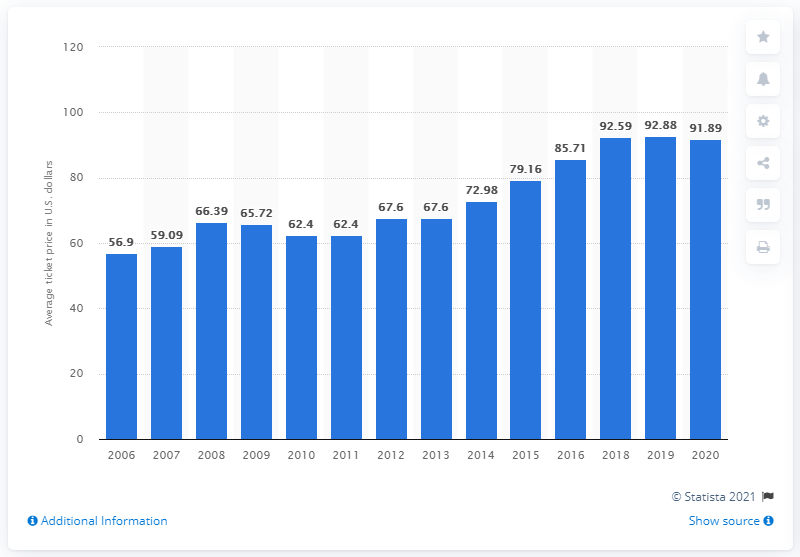Outline some significant characteristics in this image. The average ticket price for Detroit Lions games in 2020 was $91.89. 